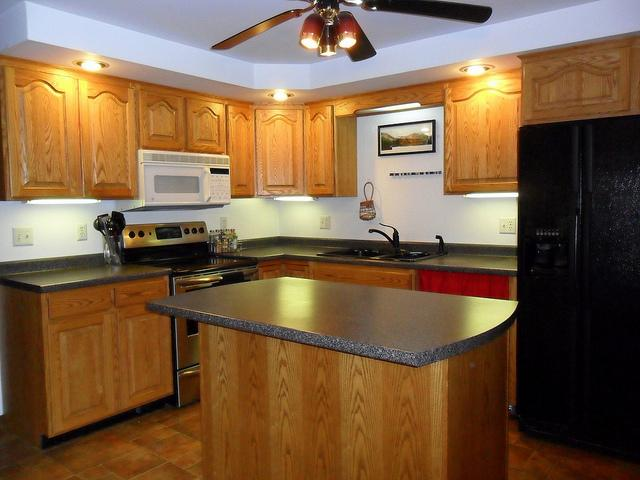What might a person make on the black and silver item on the back left? eggs 